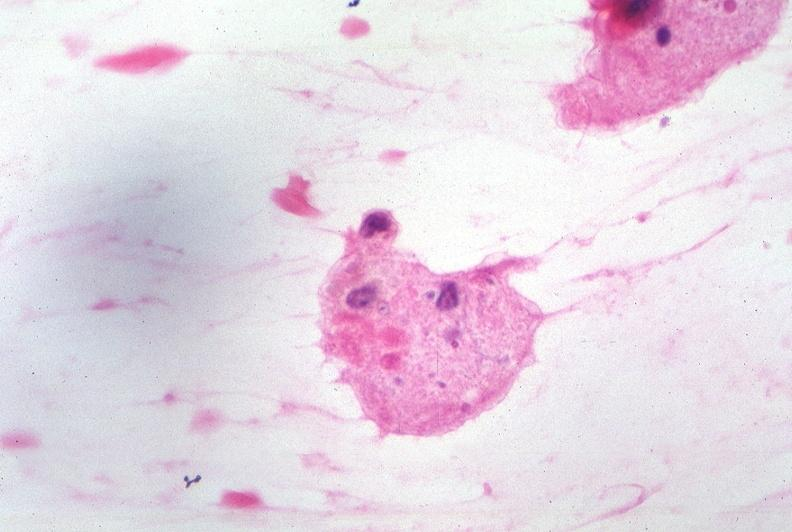what does this image show?
Answer the question using a single word or phrase. Touch impression from cerebrospinal fluid - toxoplasma 